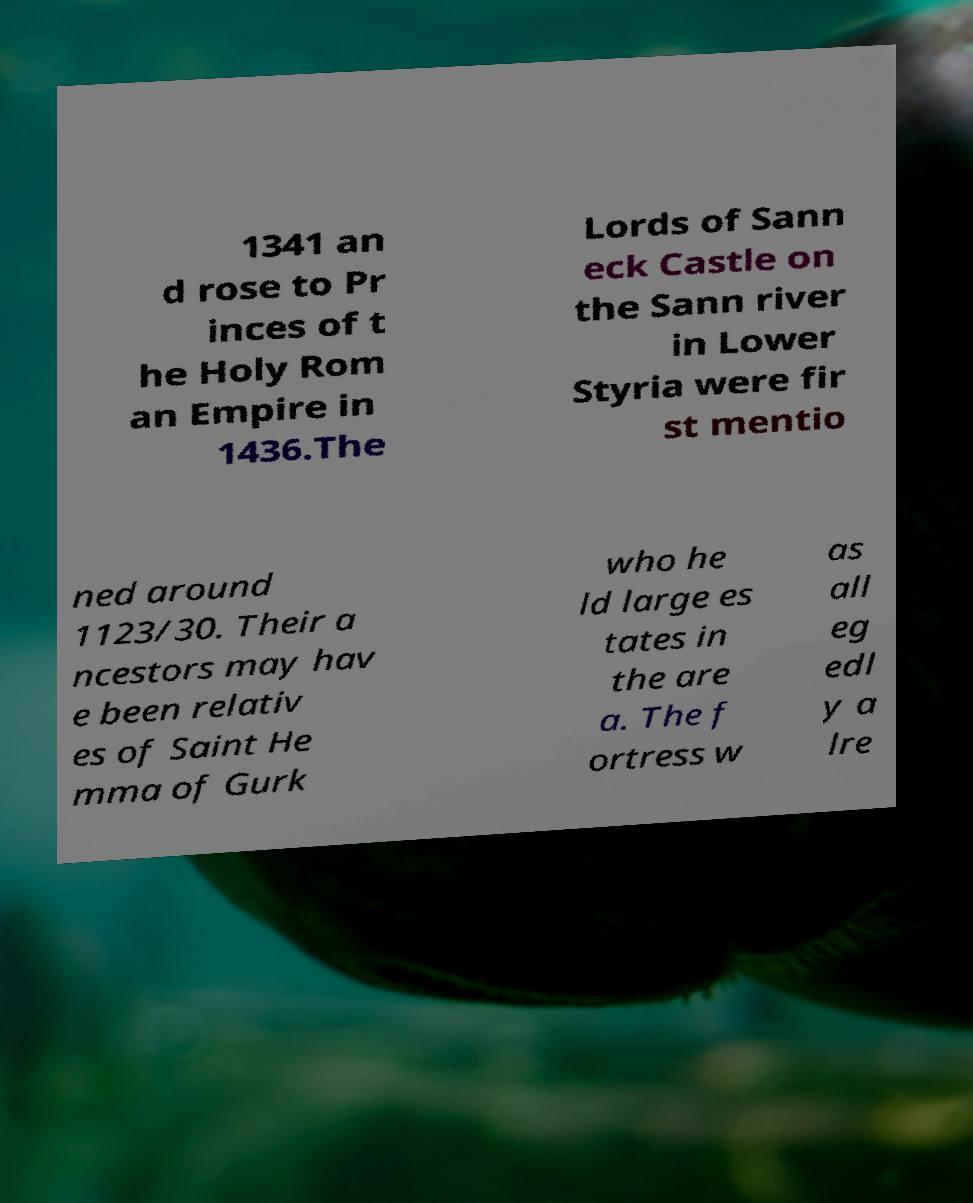There's text embedded in this image that I need extracted. Can you transcribe it verbatim? 1341 an d rose to Pr inces of t he Holy Rom an Empire in 1436.The Lords of Sann eck Castle on the Sann river in Lower Styria were fir st mentio ned around 1123/30. Their a ncestors may hav e been relativ es of Saint He mma of Gurk who he ld large es tates in the are a. The f ortress w as all eg edl y a lre 